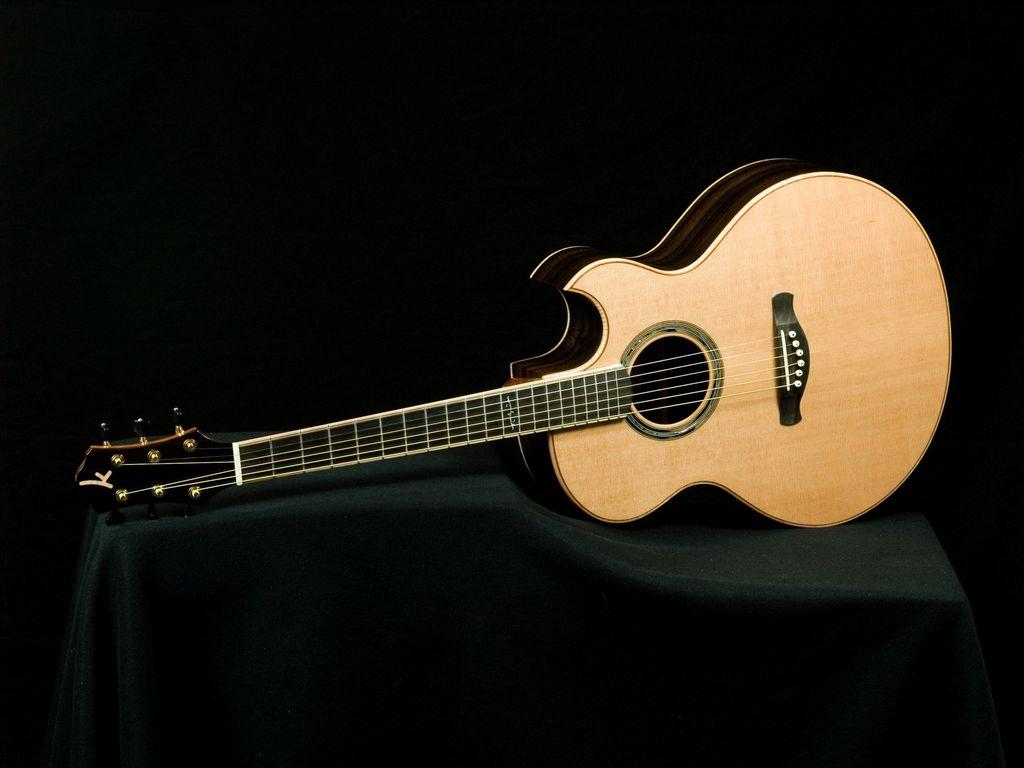What is on the table in the image? There is a guitar on the table in the image. What is covering the table in the image? There is a table cloth covering the table in the image. What type of throat lozenge is visible on the table in the image? There is no throat lozenge present on the table in the image. How many chairs are visible around the table in the image? There is no chair visible in the image. What type of bun is sitting on the guitar in the image? There is no bun present on the guitar in the image. 